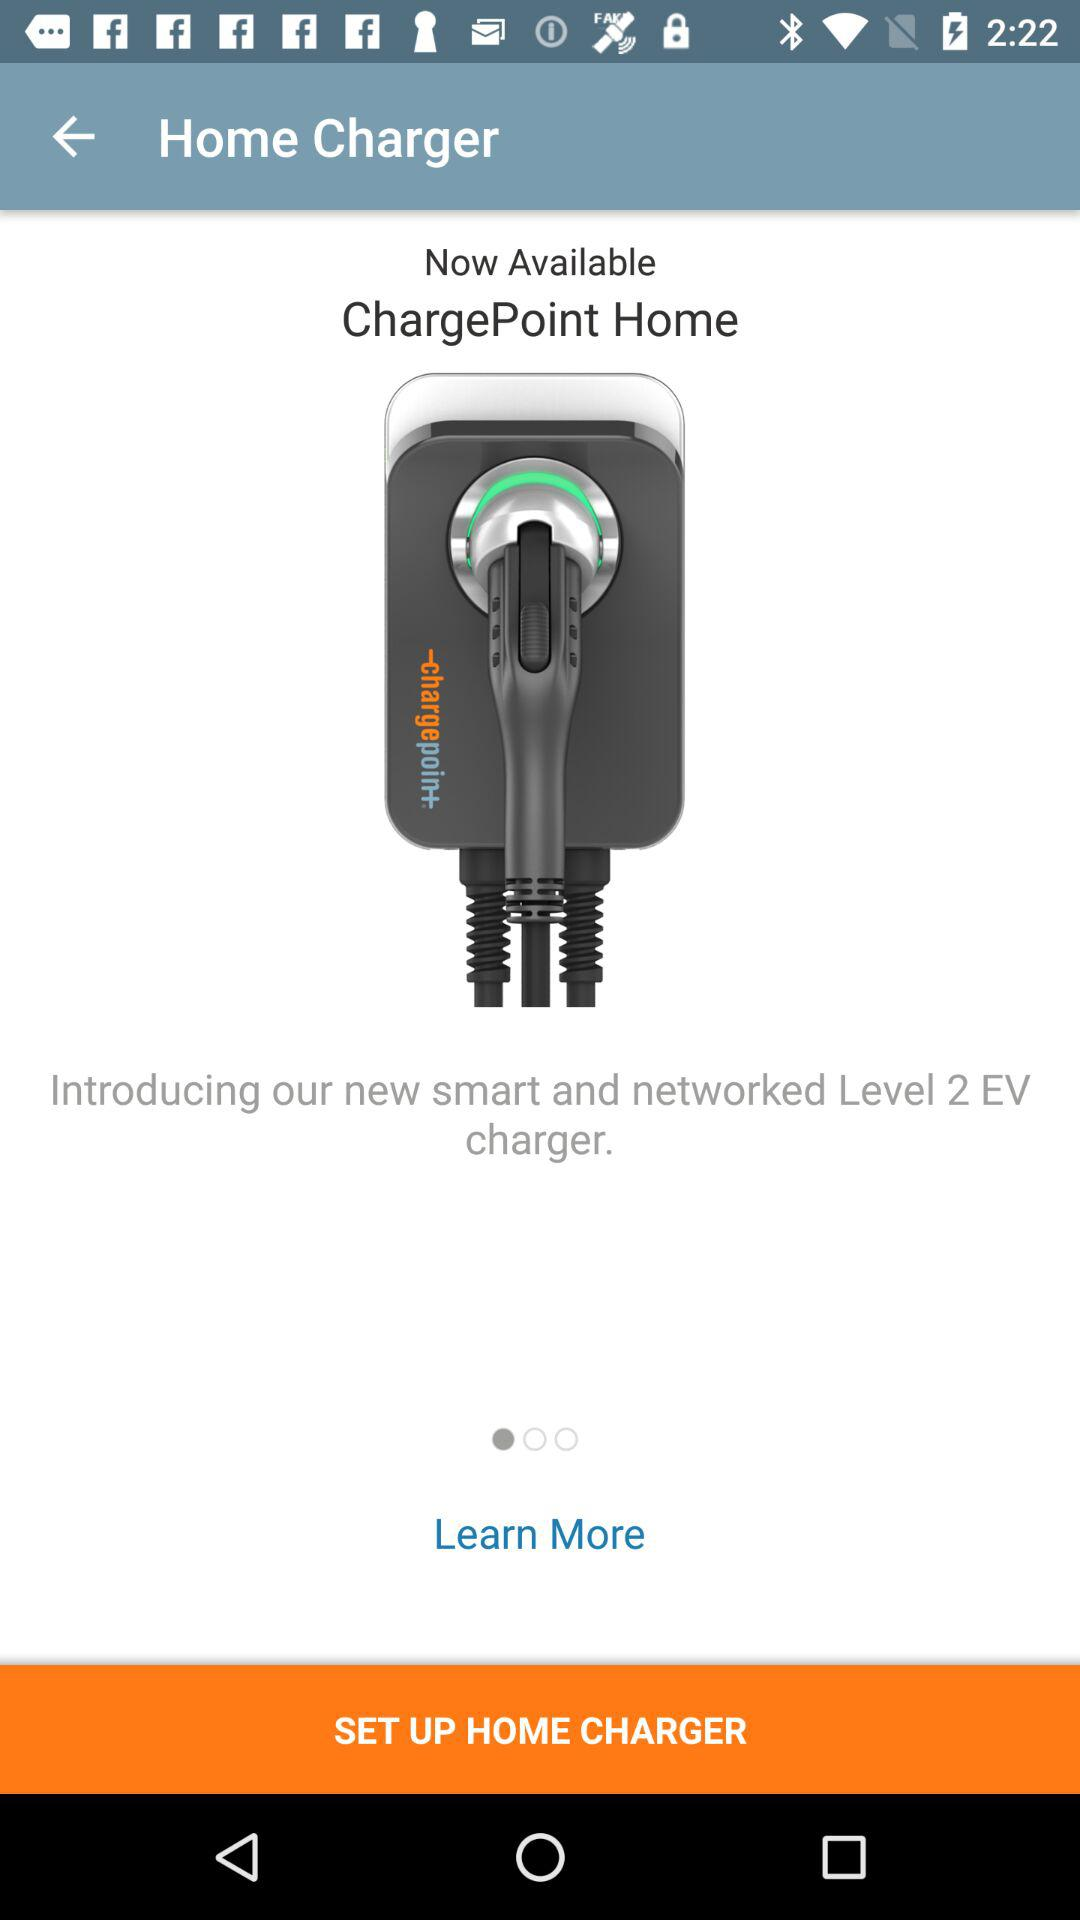Which device is the charger compatible with?
When the provided information is insufficient, respond with <no answer>. <no answer> 